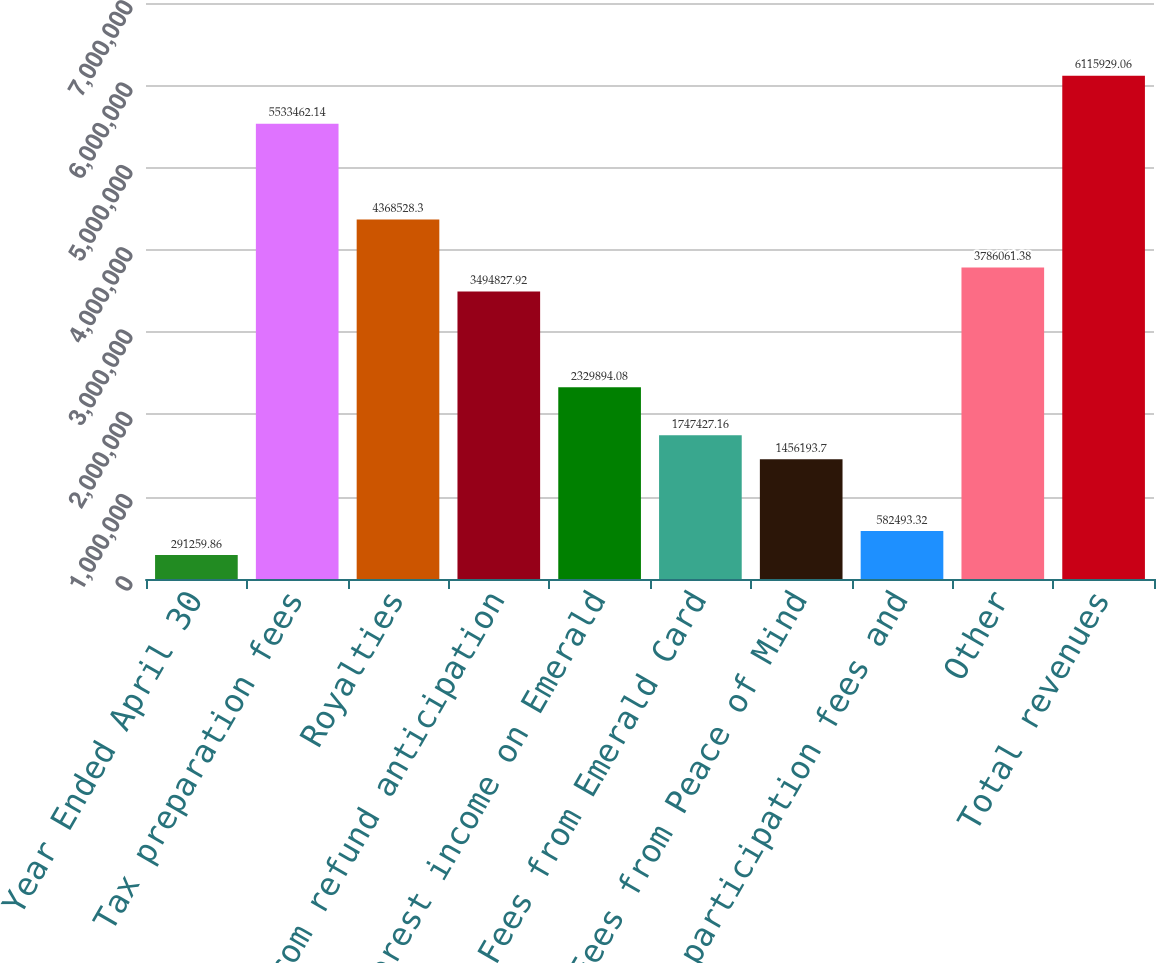Convert chart. <chart><loc_0><loc_0><loc_500><loc_500><bar_chart><fcel>Year Ended April 30<fcel>Tax preparation fees<fcel>Royalties<fcel>Fees from refund anticipation<fcel>Interest income on Emerald<fcel>Fees from Emerald Card<fcel>Fees from Peace of Mind<fcel>Loan participation fees and<fcel>Other<fcel>Total revenues<nl><fcel>291260<fcel>5.53346e+06<fcel>4.36853e+06<fcel>3.49483e+06<fcel>2.32989e+06<fcel>1.74743e+06<fcel>1.45619e+06<fcel>582493<fcel>3.78606e+06<fcel>6.11593e+06<nl></chart> 